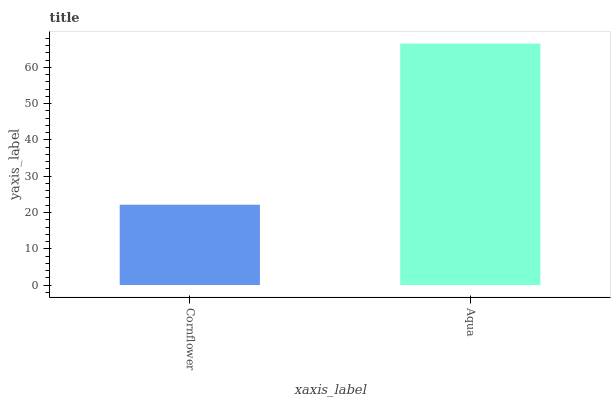Is Cornflower the minimum?
Answer yes or no. Yes. Is Aqua the maximum?
Answer yes or no. Yes. Is Aqua the minimum?
Answer yes or no. No. Is Aqua greater than Cornflower?
Answer yes or no. Yes. Is Cornflower less than Aqua?
Answer yes or no. Yes. Is Cornflower greater than Aqua?
Answer yes or no. No. Is Aqua less than Cornflower?
Answer yes or no. No. Is Aqua the high median?
Answer yes or no. Yes. Is Cornflower the low median?
Answer yes or no. Yes. Is Cornflower the high median?
Answer yes or no. No. Is Aqua the low median?
Answer yes or no. No. 